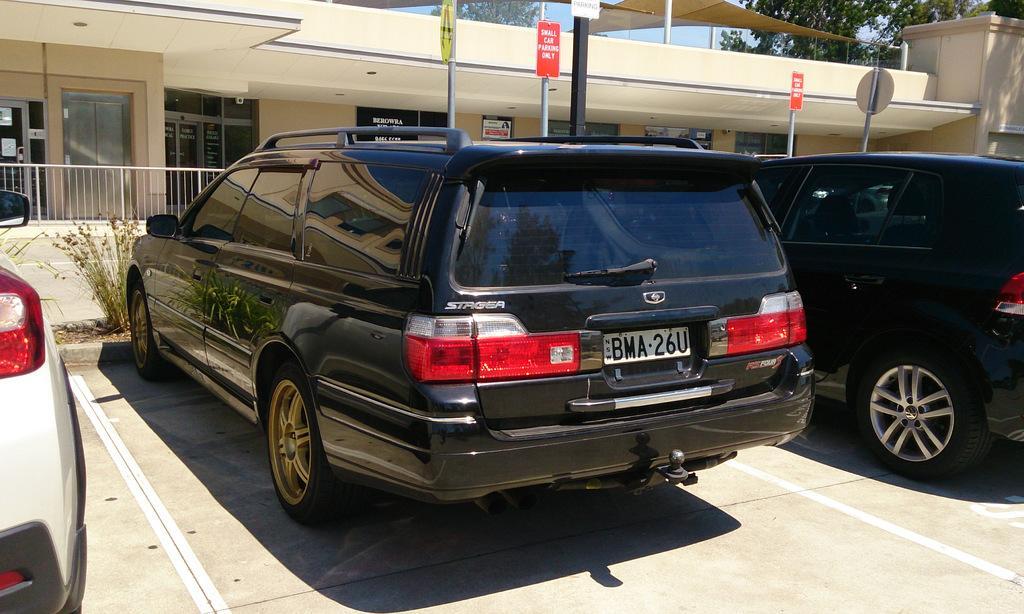Can you describe this image briefly? In this image in the front there are cars. In the background there are boards with some text written on it and there is a building and there are trees and there is a railing. 